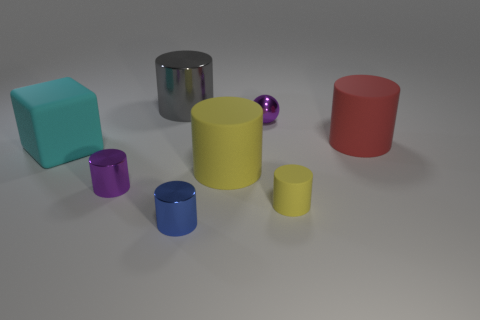Does the yellow rubber thing that is in front of the tiny purple cylinder have the same size as the purple metal thing in front of the large red object?
Your answer should be very brief. Yes. What shape is the purple shiny thing right of the small metal cylinder that is in front of the tiny purple shiny thing that is on the left side of the small blue shiny object?
Offer a very short reply. Sphere. There is a purple object that is the same shape as the blue metal thing; what size is it?
Offer a very short reply. Small. The large matte thing that is right of the matte block and in front of the big red object is what color?
Keep it short and to the point. Yellow. Is the cyan cube made of the same material as the purple thing in front of the block?
Keep it short and to the point. No. Are there fewer large gray things that are in front of the blue shiny cylinder than rubber objects?
Your answer should be compact. Yes. How many other things are the same shape as the large metal object?
Provide a short and direct response. 5. Is there anything else of the same color as the cube?
Your response must be concise. No. Do the big shiny thing and the large rubber cylinder to the right of the large yellow rubber cylinder have the same color?
Offer a terse response. No. What number of other things are there of the same size as the blue cylinder?
Your answer should be very brief. 3. 